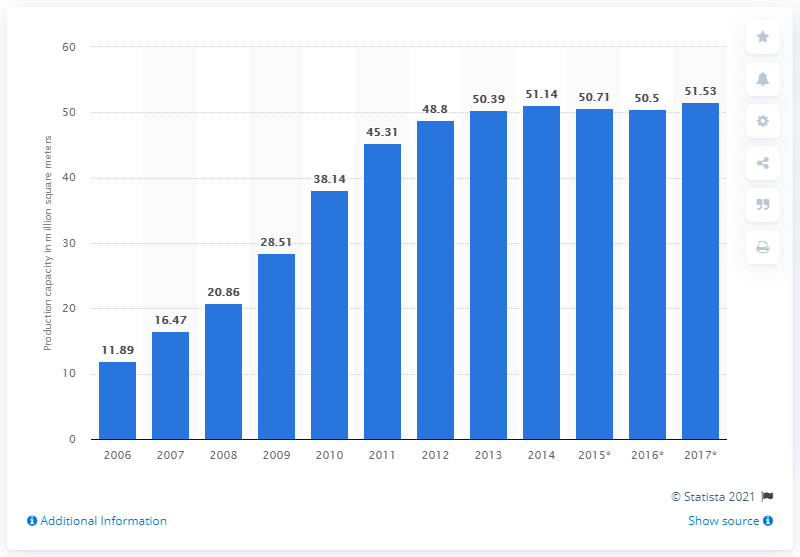Identify some key points in this picture. LGD's production capacity in square meters in 2014 was 51.53. 